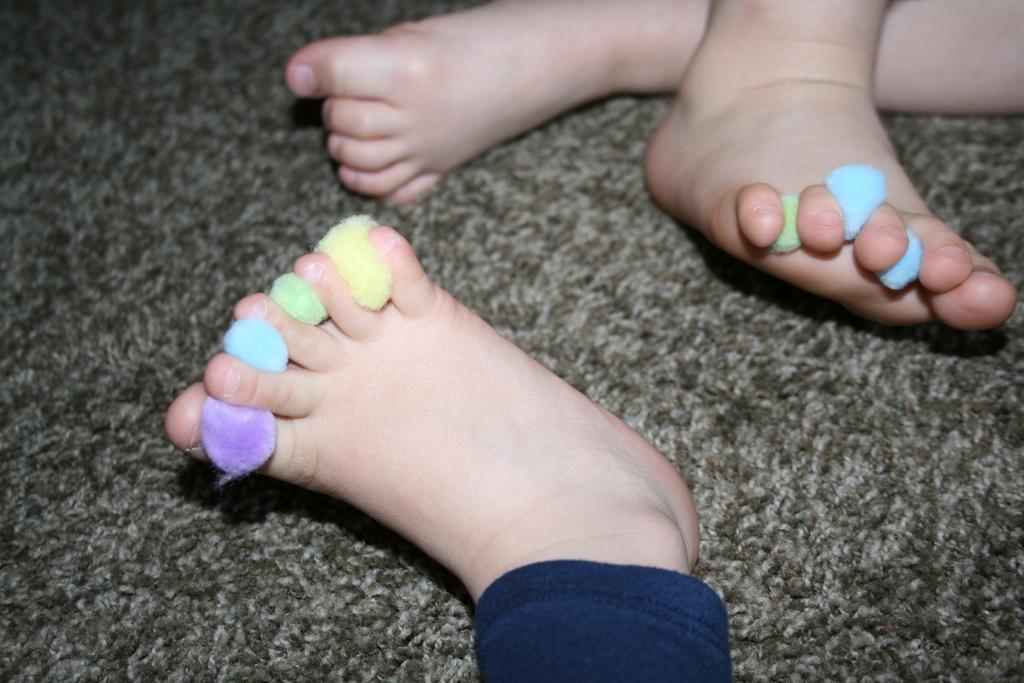Describe this image in one or two sentences. There are legs of kids which has few objects placed in between the fingers of it. 